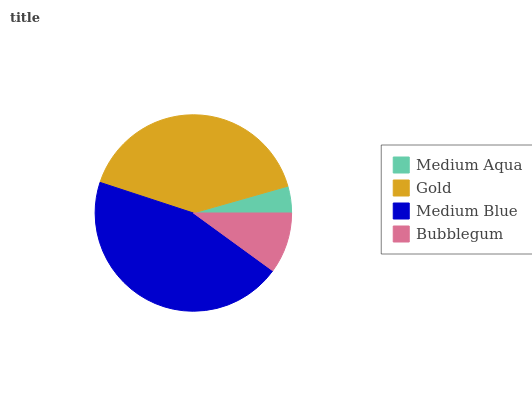Is Medium Aqua the minimum?
Answer yes or no. Yes. Is Medium Blue the maximum?
Answer yes or no. Yes. Is Gold the minimum?
Answer yes or no. No. Is Gold the maximum?
Answer yes or no. No. Is Gold greater than Medium Aqua?
Answer yes or no. Yes. Is Medium Aqua less than Gold?
Answer yes or no. Yes. Is Medium Aqua greater than Gold?
Answer yes or no. No. Is Gold less than Medium Aqua?
Answer yes or no. No. Is Gold the high median?
Answer yes or no. Yes. Is Bubblegum the low median?
Answer yes or no. Yes. Is Medium Aqua the high median?
Answer yes or no. No. Is Medium Aqua the low median?
Answer yes or no. No. 